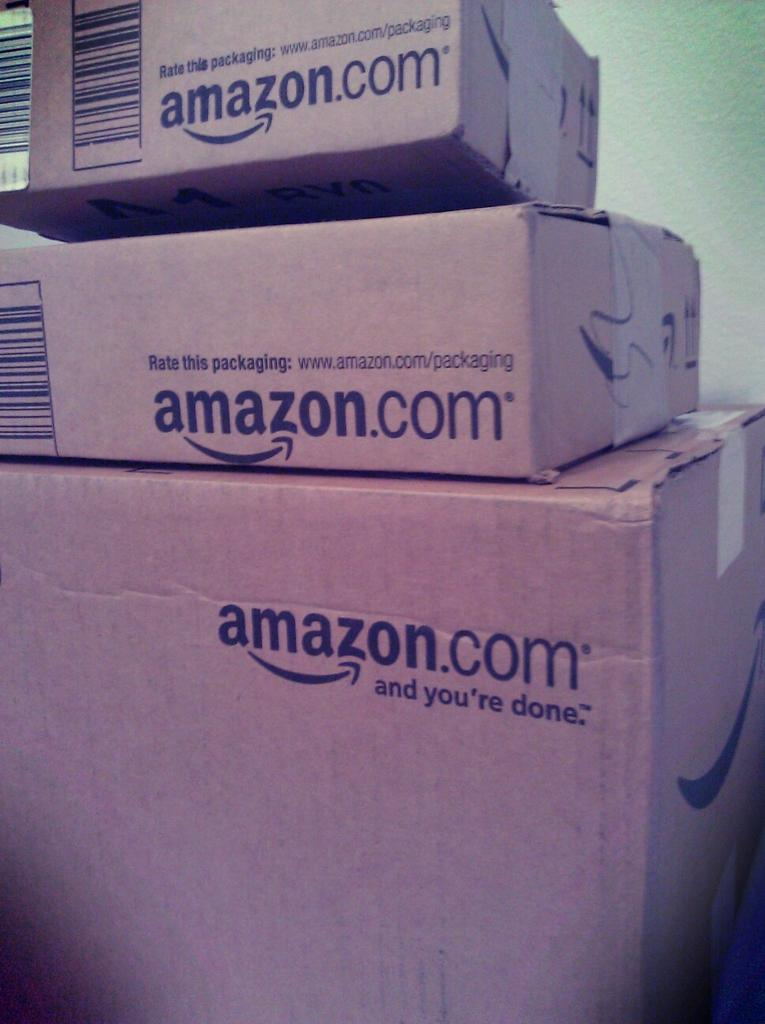<image>
Write a terse but informative summary of the picture. Three stacked brown closed cardboard boxes from amazon.com 